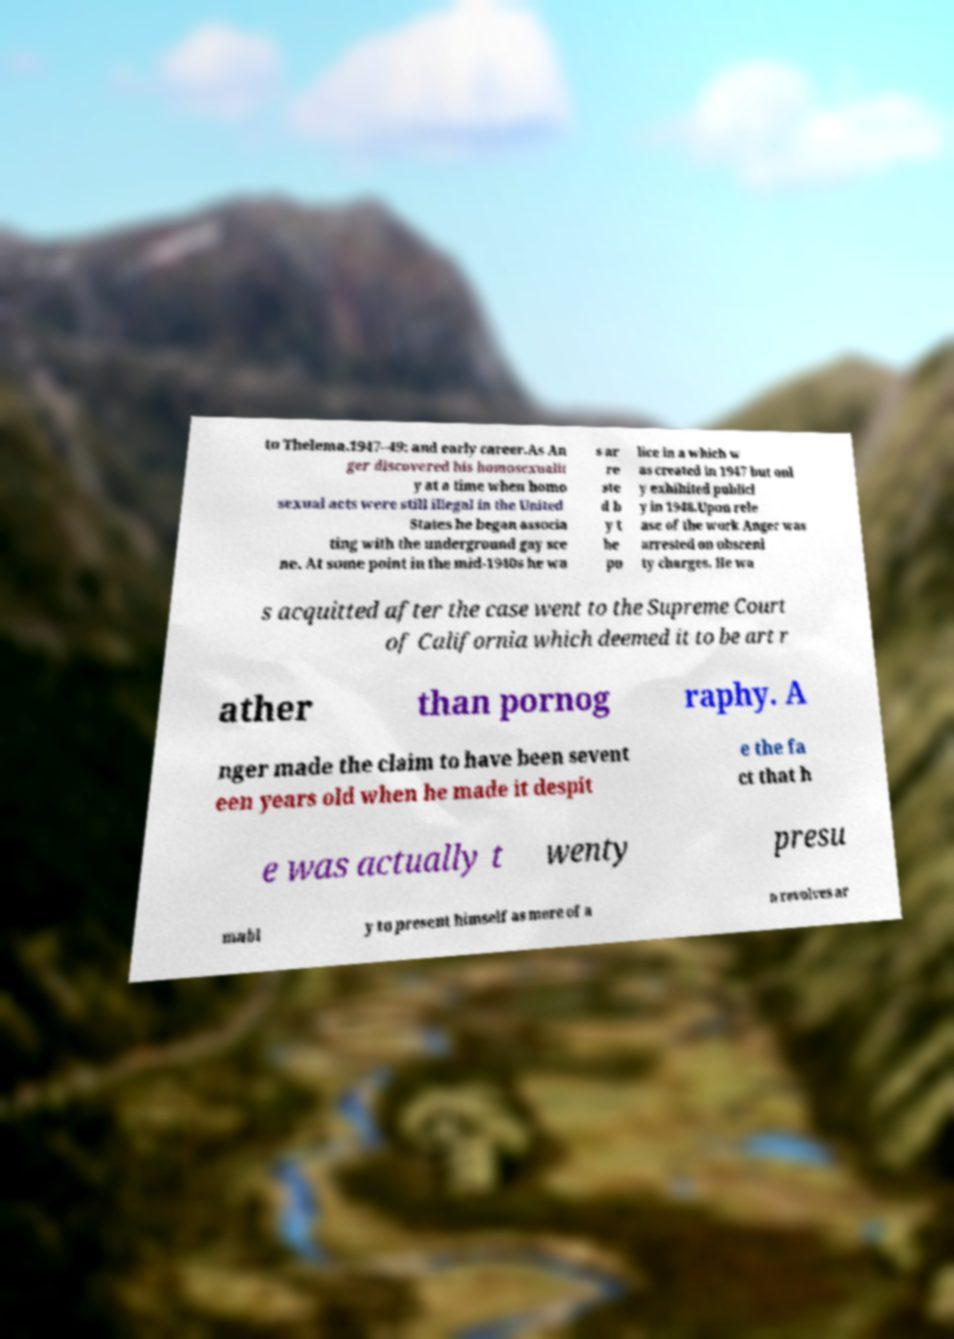There's text embedded in this image that I need extracted. Can you transcribe it verbatim? to Thelema.1947–49: and early career.As An ger discovered his homosexualit y at a time when homo sexual acts were still illegal in the United States he began associa ting with the underground gay sce ne. At some point in the mid-1940s he wa s ar re ste d b y t he po lice in a which w as created in 1947 but onl y exhibited publicl y in 1948.Upon rele ase of the work Anger was arrested on obsceni ty charges. He wa s acquitted after the case went to the Supreme Court of California which deemed it to be art r ather than pornog raphy. A nger made the claim to have been sevent een years old when he made it despit e the fa ct that h e was actually t wenty presu mabl y to present himself as more of a n revolves ar 